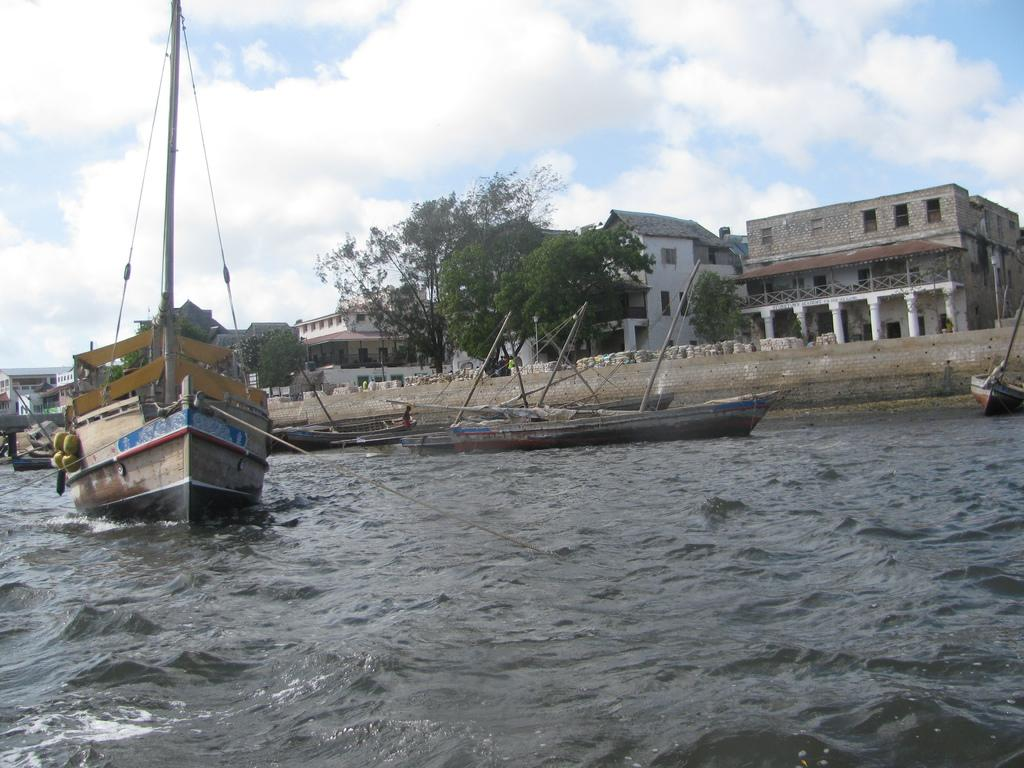What type of structures can be seen in the image? There are buildings in the image. What other natural elements are present in the image? There are trees in the image. What can be seen in the water in the image? There are boats in the water in the image. How would you describe the sky in the image? The sky is blue and cloudy. Where is the patch of grass located in the image? There is no patch of grass present in the image. What type of railway can be seen in the image? There is no railway present in the image. 